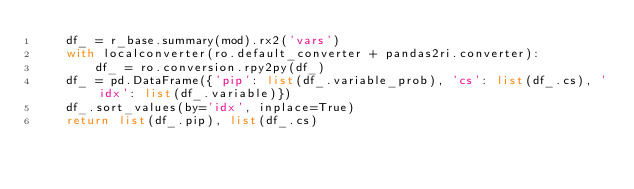<code> <loc_0><loc_0><loc_500><loc_500><_Python_>    df_ = r_base.summary(mod).rx2('vars')
    with localconverter(ro.default_converter + pandas2ri.converter):
        df_ = ro.conversion.rpy2py(df_)
    df_ = pd.DataFrame({'pip': list(df_.variable_prob), 'cs': list(df_.cs), 'idx': list(df_.variable)})
    df_.sort_values(by='idx', inplace=True)
    return list(df_.pip), list(df_.cs)</code> 